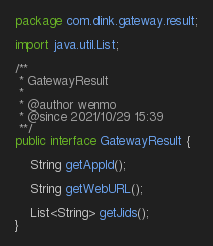Convert code to text. <code><loc_0><loc_0><loc_500><loc_500><_Java_>package com.dlink.gateway.result;

import java.util.List;

/**
 * GatewayResult
 *
 * @author wenmo
 * @since 2021/10/29 15:39
 **/
public interface GatewayResult {

    String getAppId();

    String getWebURL();

    List<String> getJids();
}
</code> 